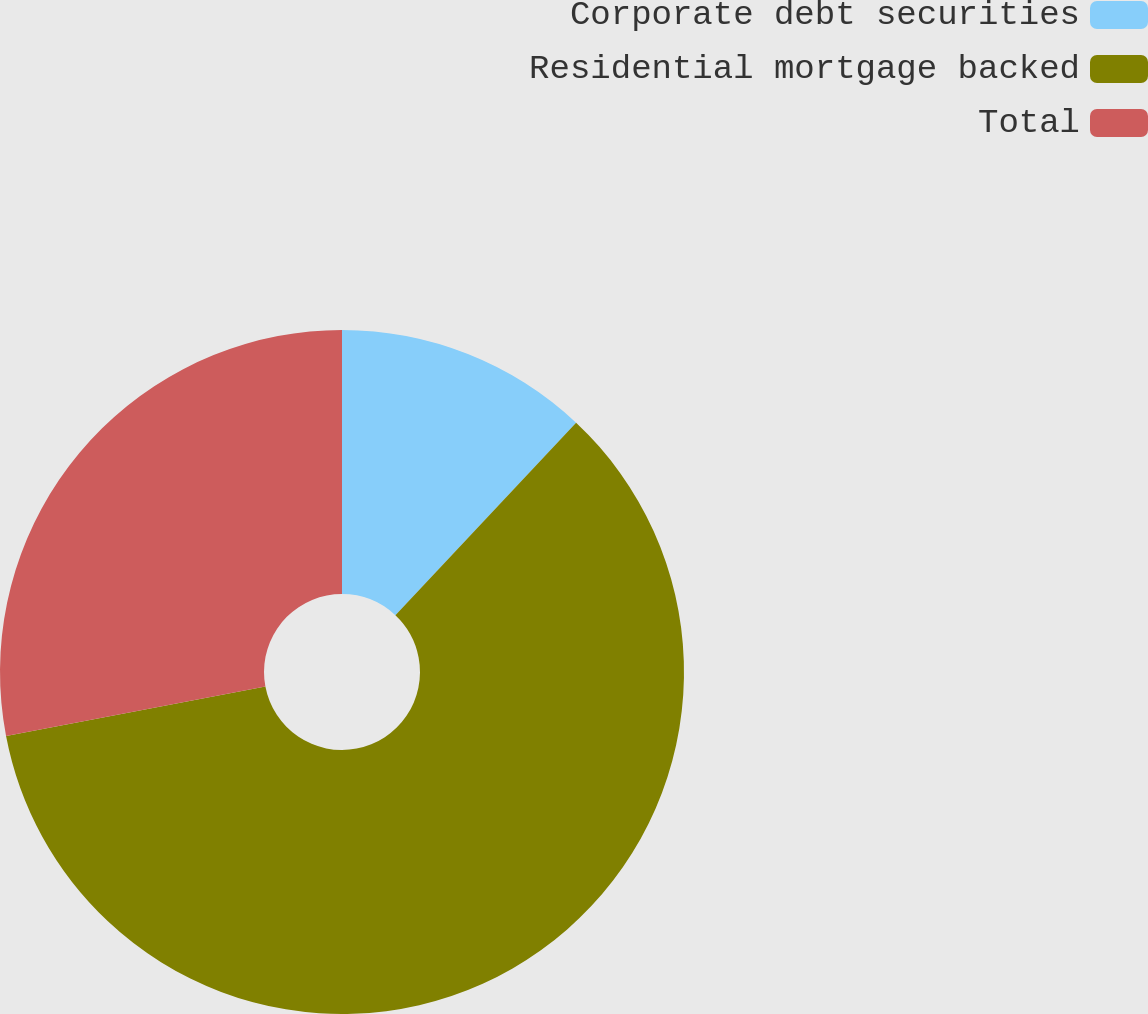Convert chart. <chart><loc_0><loc_0><loc_500><loc_500><pie_chart><fcel>Corporate debt securities<fcel>Residential mortgage backed<fcel>Total<nl><fcel>12.0%<fcel>60.0%<fcel>28.0%<nl></chart> 